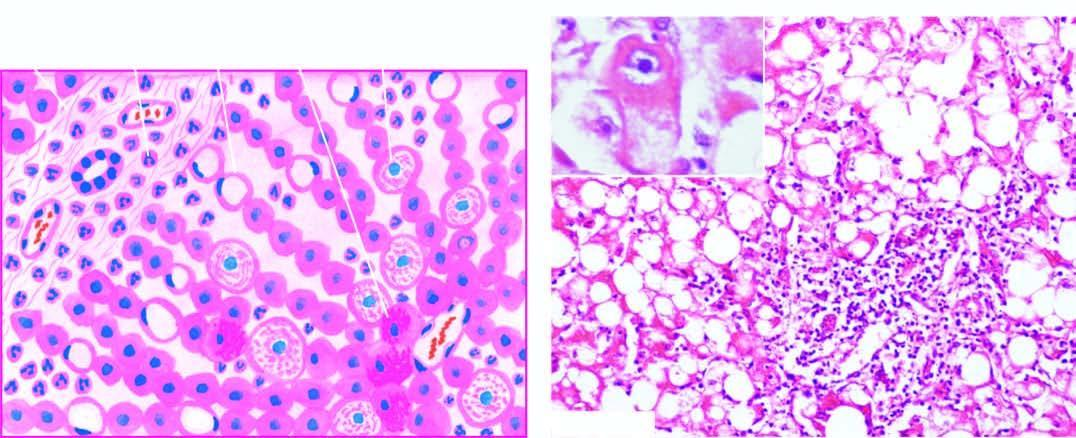re defects in any of the six also present?
Answer the question using a single word or phrase. No 